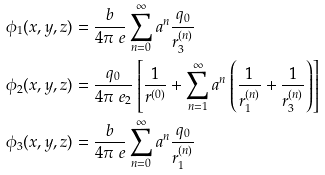<formula> <loc_0><loc_0><loc_500><loc_500>\phi _ { 1 } ( x , y , z ) & = \frac { b } { 4 \pi \ e } \sum _ { n = 0 } ^ { \infty } a ^ { n } \frac { q _ { 0 } } { r _ { 3 } ^ { ( n ) } } \\ \phi _ { 2 } ( x , y , z ) & = \frac { q _ { 0 } } { 4 \pi \ e _ { 2 } } \left [ \frac { 1 } { r ^ { ( 0 ) } } + \sum _ { n = 1 } ^ { \infty } a ^ { n } \left ( \frac { 1 } { r _ { 1 } ^ { ( n ) } } + \frac { 1 } { r _ { 3 } ^ { ( n ) } } \right ) \right ] \\ \phi _ { 3 } ( x , y , z ) & = \frac { b } { 4 \pi \ e } \sum _ { n = 0 } ^ { \infty } a ^ { n } \frac { q _ { 0 } } { r _ { 1 } ^ { ( n ) } }</formula> 